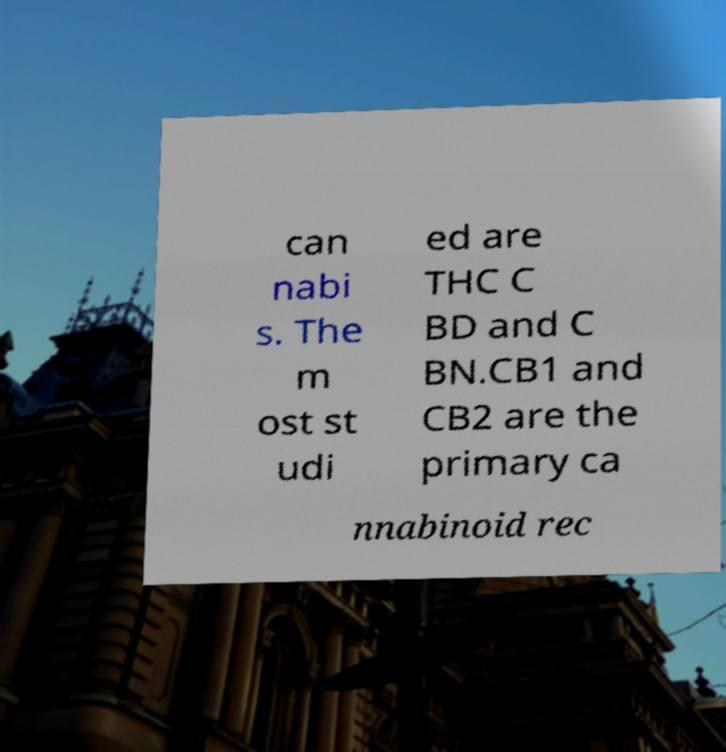There's text embedded in this image that I need extracted. Can you transcribe it verbatim? can nabi s. The m ost st udi ed are THC C BD and C BN.CB1 and CB2 are the primary ca nnabinoid rec 